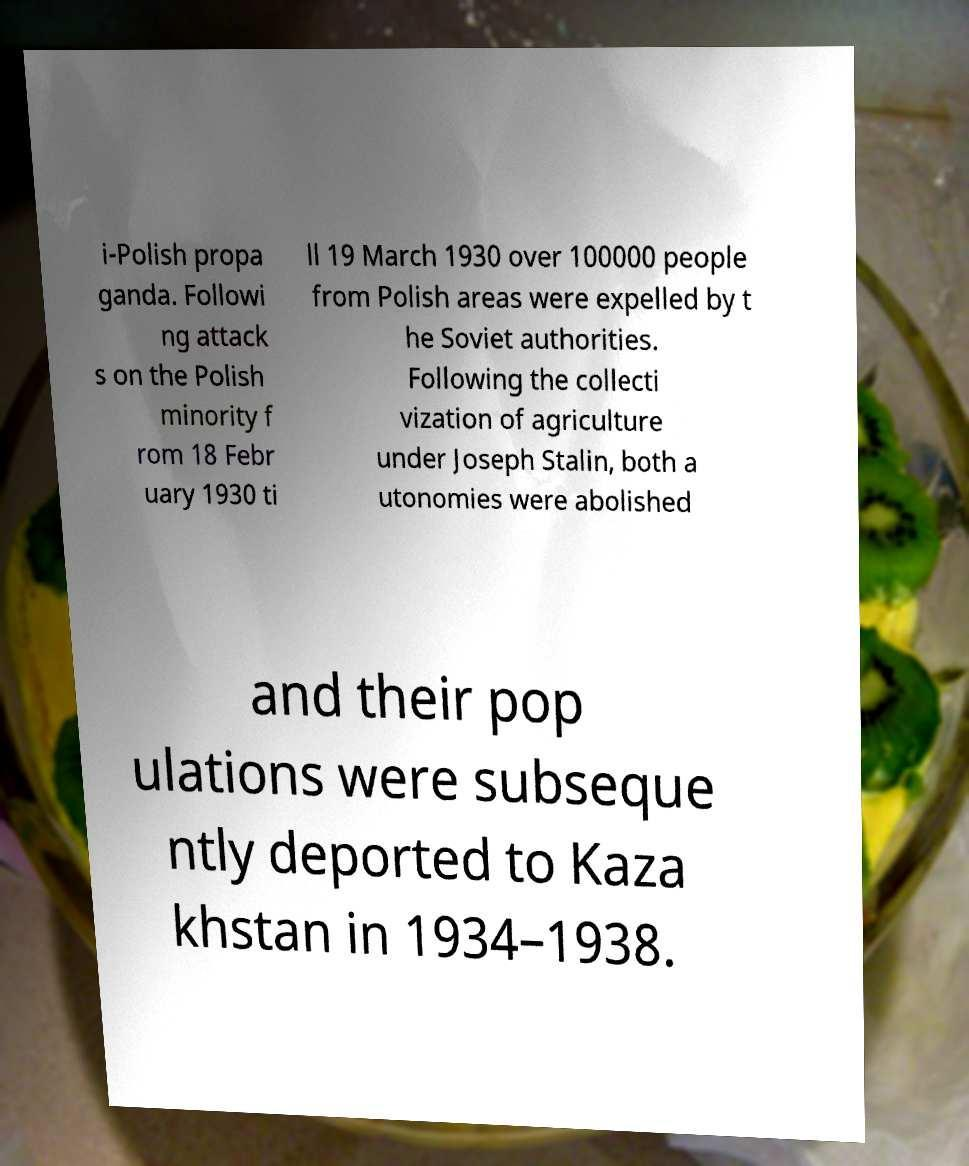Could you extract and type out the text from this image? i-Polish propa ganda. Followi ng attack s on the Polish minority f rom 18 Febr uary 1930 ti ll 19 March 1930 over 100000 people from Polish areas were expelled by t he Soviet authorities. Following the collecti vization of agriculture under Joseph Stalin, both a utonomies were abolished and their pop ulations were subseque ntly deported to Kaza khstan in 1934–1938. 